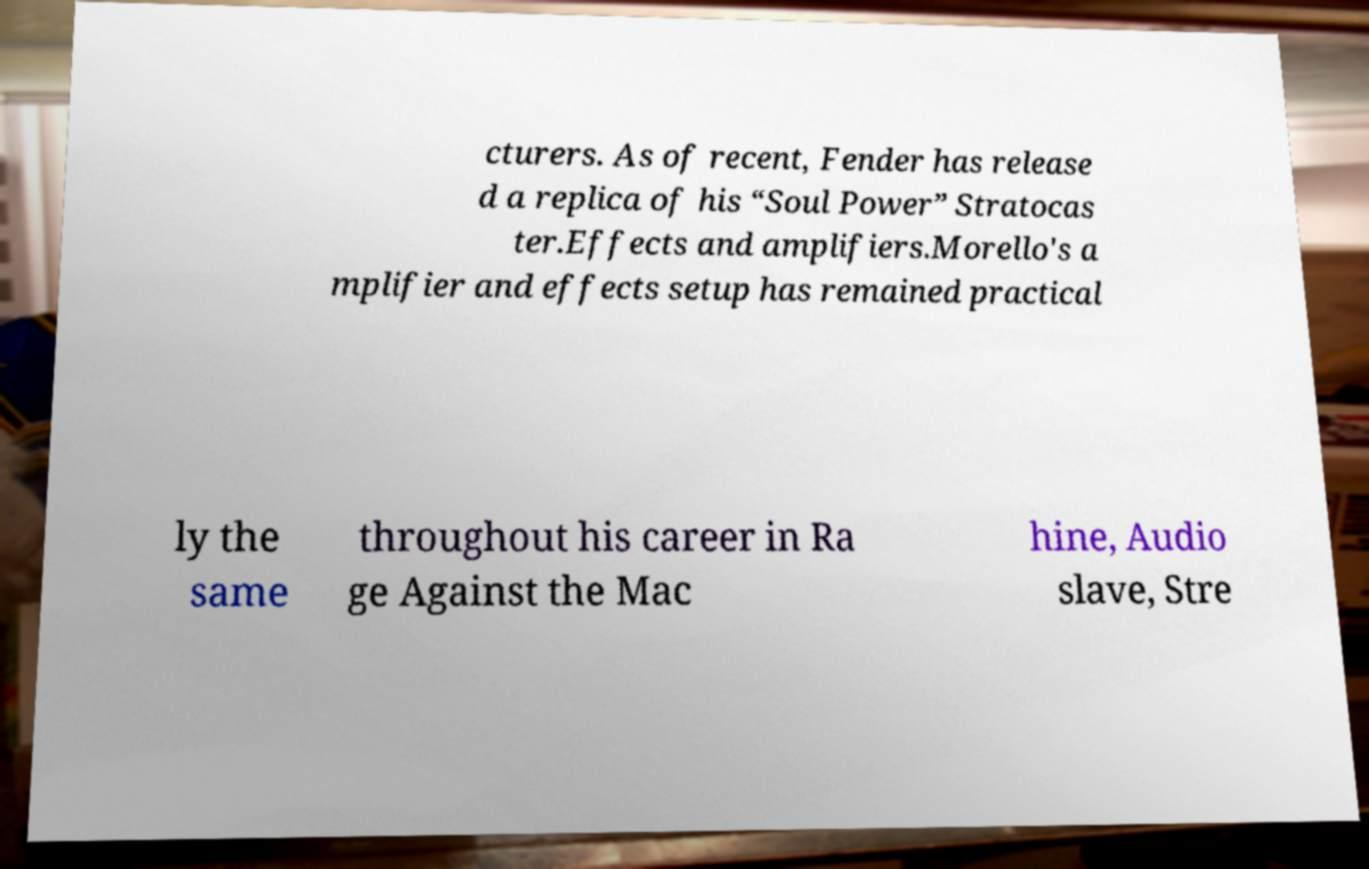Can you accurately transcribe the text from the provided image for me? cturers. As of recent, Fender has release d a replica of his “Soul Power” Stratocas ter.Effects and amplifiers.Morello's a mplifier and effects setup has remained practical ly the same throughout his career in Ra ge Against the Mac hine, Audio slave, Stre 